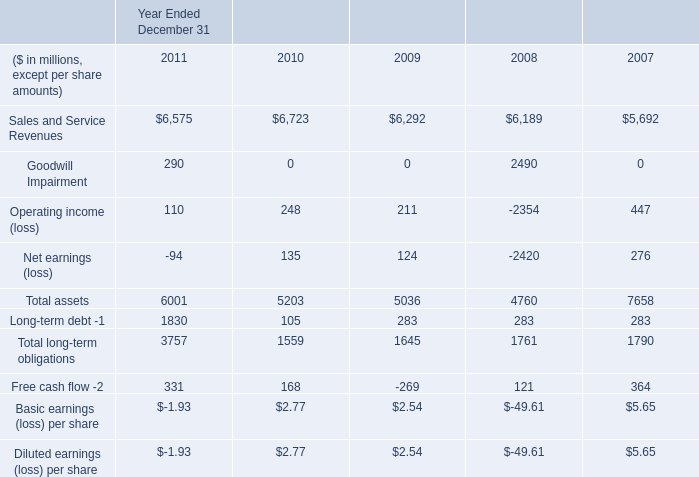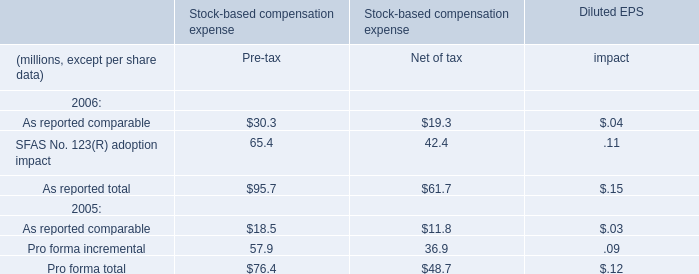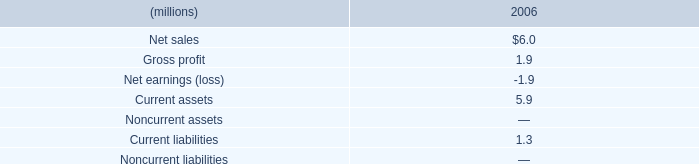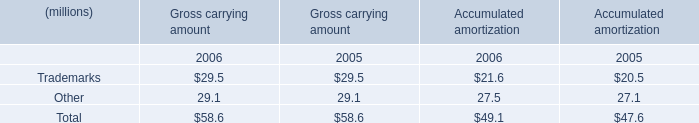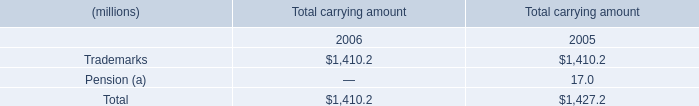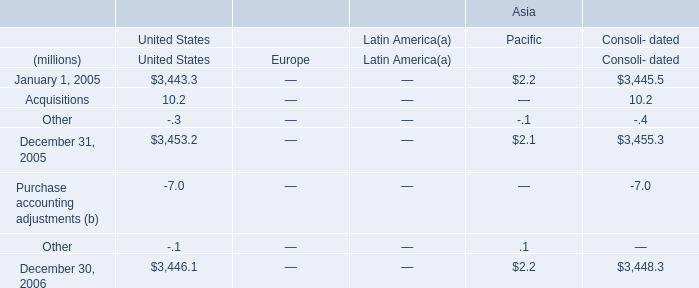What is the growth rate of the Total carrying amount for Total between 2005 and 2006? 
Computations: ((1410.2 - 1427.2) / 1427.2)
Answer: -0.01191. 